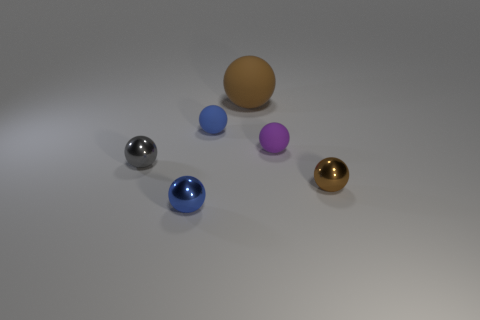How many brown spheres must be subtracted to get 1 brown spheres? 1 Add 2 big gray cubes. How many objects exist? 8 Subtract all small brown spheres. How many spheres are left? 5 Subtract all purple spheres. How many spheres are left? 5 Add 5 brown rubber spheres. How many brown rubber spheres exist? 6 Subtract 0 brown blocks. How many objects are left? 6 Subtract 2 balls. How many balls are left? 4 Subtract all brown spheres. Subtract all gray cylinders. How many spheres are left? 4 Subtract all cyan cylinders. How many purple balls are left? 1 Subtract all yellow metallic cylinders. Subtract all blue metallic things. How many objects are left? 5 